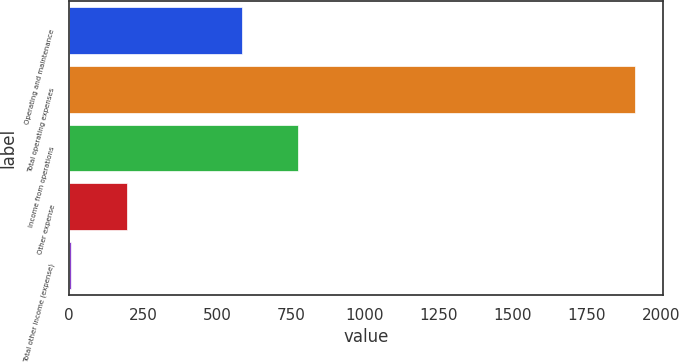Convert chart. <chart><loc_0><loc_0><loc_500><loc_500><bar_chart><fcel>Operating and maintenance<fcel>Total operating expenses<fcel>Income from operations<fcel>Other expense<fcel>Total other income (expense)<nl><fcel>583.5<fcel>1912.2<fcel>774.04<fcel>197.34<fcel>6.8<nl></chart> 